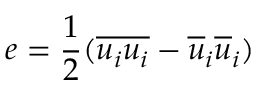<formula> <loc_0><loc_0><loc_500><loc_500>e = \frac { 1 } { 2 } ( \overline { { u _ { i } u _ { i } } } - \overline { u } _ { i } \overline { u } _ { i } )</formula> 